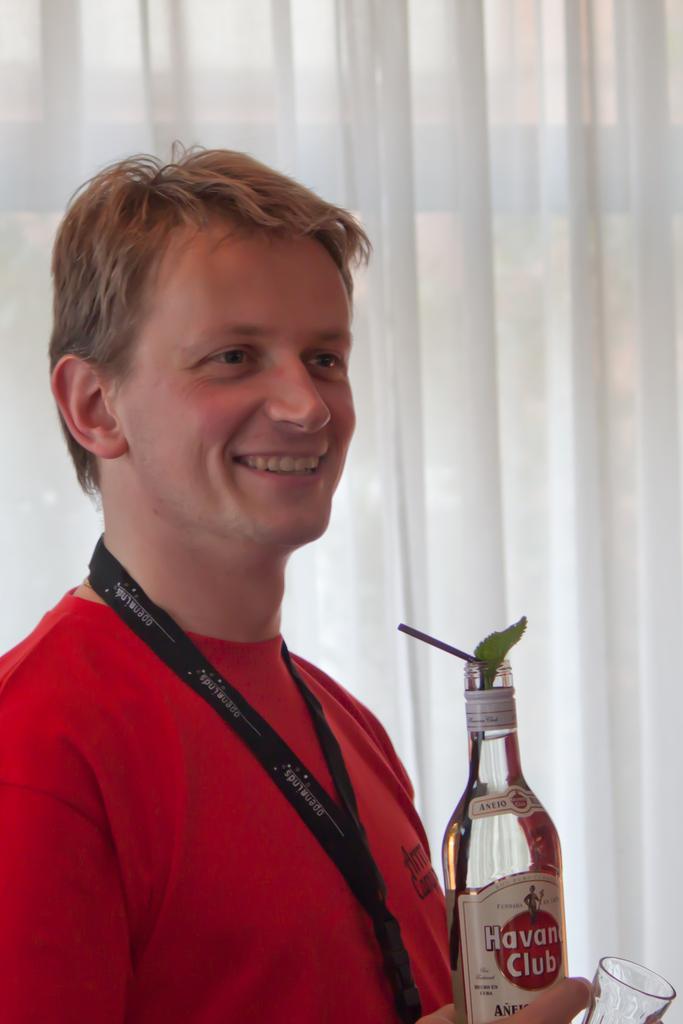Could you give a brief overview of what you see in this image? In the image we can see one man standing and smiling,he is holding bottle named as "Club". And back there is a curtain. 